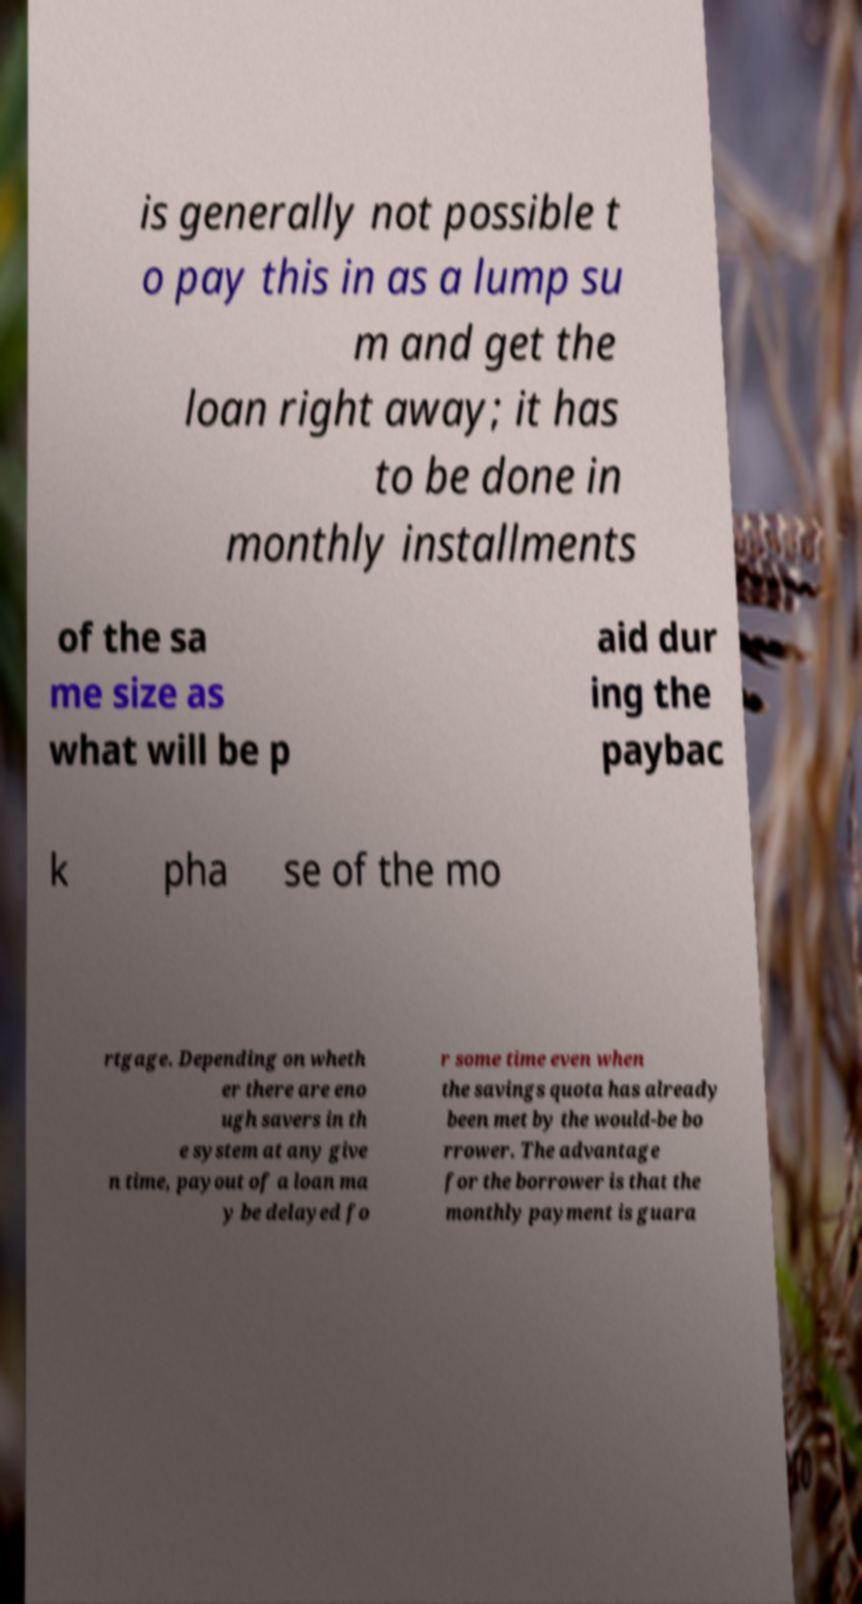Please identify and transcribe the text found in this image. is generally not possible t o pay this in as a lump su m and get the loan right away; it has to be done in monthly installments of the sa me size as what will be p aid dur ing the paybac k pha se of the mo rtgage. Depending on wheth er there are eno ugh savers in th e system at any give n time, payout of a loan ma y be delayed fo r some time even when the savings quota has already been met by the would-be bo rrower. The advantage for the borrower is that the monthly payment is guara 